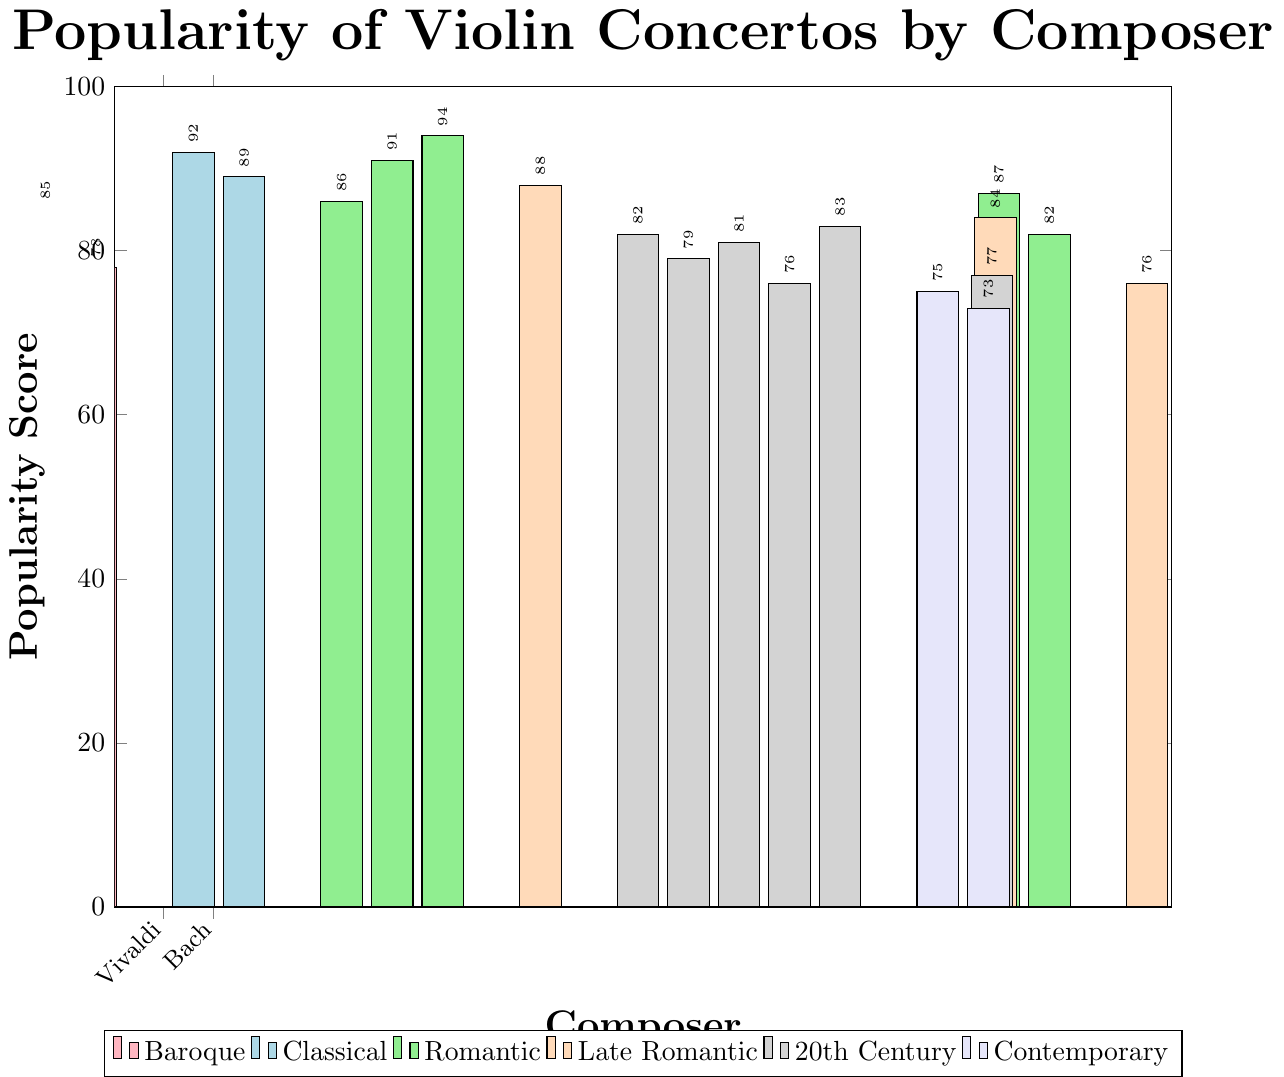Which composer has the highest popularity score in the Romantic era? To find this, look at the bars colored in green representing the Romantic era. The highest bar among these is for Tchaikovsky, with a score of 94.
Answer: Tchaikovsky How does the popularity score of Vivaldi compare with Mozart? Find the bars for Vivaldi and Mozart, which represent Baroque and Classical eras respectively. Vivaldi has a score of 85, while Mozart has a score of 92.
Answer: Vivaldi's score is 7 points less than Mozart's What's the sum of popularity scores for composers from the Baroque era? Sum the scores for Vivaldi (85) and Bach (78). 85 + 78 = 163
Answer: 163 Which era has the lowest average popularity score? Calculate the average popularity score for each era: Baroque (81.5), Classical (90.5), Romantic (88), Late Romantic (82.6), 20th Century (79.75), Contemporary (74). The lowest average is for the Contemporary era with 74.
Answer: Contemporary What is the difference in popularity scores between Mendelssohn and Brahms? Find the bars for Mendelssohn and Brahms in the Romantic era. Mendelssohn has a score of 86, and Brahms has a score of 91. The difference is 91 - 86 = 5.
Answer: 5 Is there any composer with a popularity score of exactly 75? Look for any bar marked with a popularity score of 75. The composer Glass, in the Contemporary era has this score.
Answer: Yes, Glass Which composer from the 20th century has the highest popularity score? Look at the bars representing the 20th century, colored in grey. The highest bar is for Barber with a score of 83.
Answer: Barber What is the combined total of popularity scores for Beethoven and Sibelius? Add the scores for Beethoven (89) from the Classical era and Sibelius (88) from the Late Romantic era. 89 + 88 = 177.
Answer: 177 Among Late Romantic composers, who has the lowest popularity score? Check the bars for Late Romantic composers. The lowest bar is for Glazunov, with a score of 76.
Answer: Glazunov Which era features the most composers in this dataset? Count the number of composers in each era: Baroque (2), Classical (2), Romantic (5), Late Romantic (3), 20th Century (6), Contemporary (2). The 20th Century has the most composers, with 6.
Answer: 20th Century 